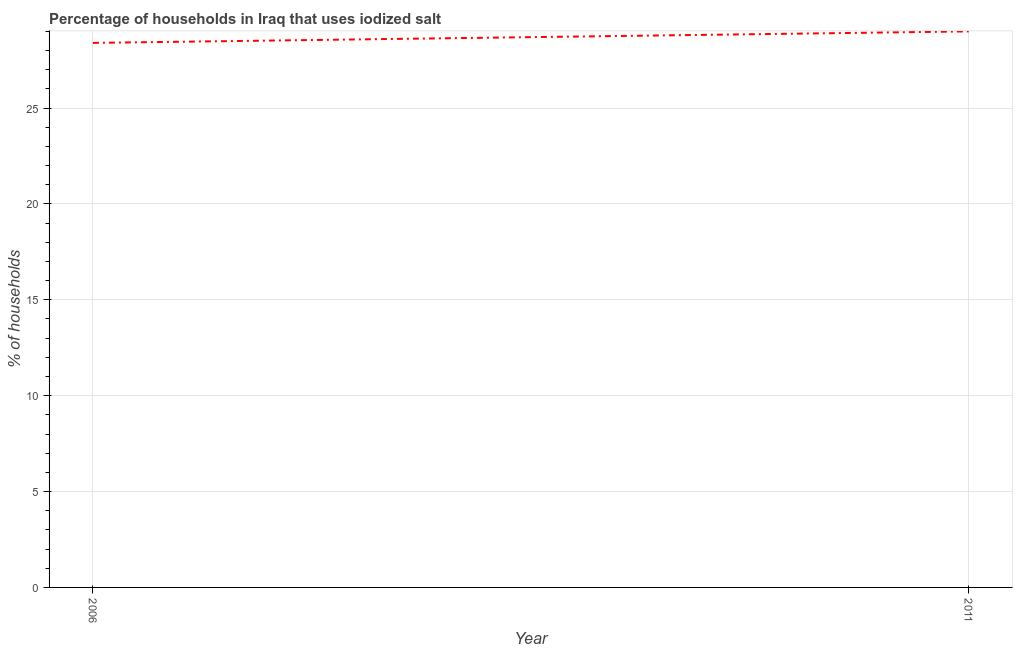What is the percentage of households where iodized salt is consumed in 2011?
Your response must be concise. 29. Across all years, what is the maximum percentage of households where iodized salt is consumed?
Your answer should be very brief. 29. Across all years, what is the minimum percentage of households where iodized salt is consumed?
Offer a very short reply. 28.4. What is the sum of the percentage of households where iodized salt is consumed?
Offer a very short reply. 57.4. What is the difference between the percentage of households where iodized salt is consumed in 2006 and 2011?
Keep it short and to the point. -0.6. What is the average percentage of households where iodized salt is consumed per year?
Make the answer very short. 28.7. What is the median percentage of households where iodized salt is consumed?
Your answer should be very brief. 28.7. In how many years, is the percentage of households where iodized salt is consumed greater than 18 %?
Your answer should be very brief. 2. What is the ratio of the percentage of households where iodized salt is consumed in 2006 to that in 2011?
Make the answer very short. 0.98. Does the graph contain any zero values?
Your answer should be very brief. No. What is the title of the graph?
Offer a terse response. Percentage of households in Iraq that uses iodized salt. What is the label or title of the Y-axis?
Ensure brevity in your answer.  % of households. What is the % of households of 2006?
Provide a short and direct response. 28.4. 